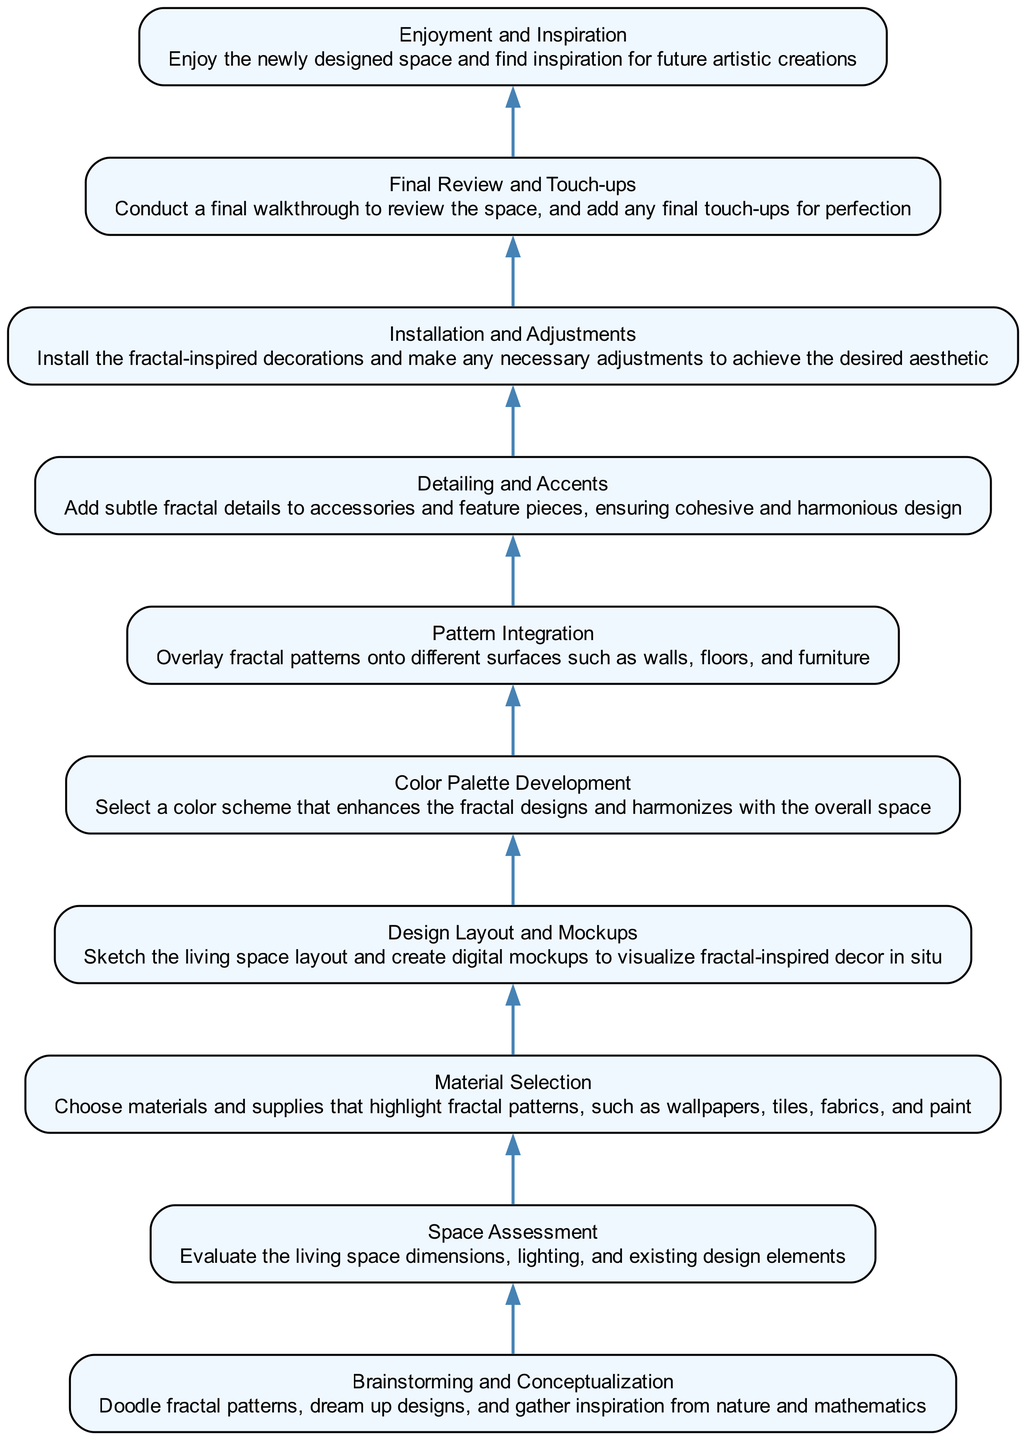What is the first step in the design process? The first step listed in the diagram is "Brainstorming and Conceptualization," which entails doodling fractal patterns and gathering inspiration.
Answer: Brainstorming and Conceptualization How many nodes are present in the diagram? The diagram contains ten nodes, each representing a specific step in the design process for creating fractal-inspired decorations.
Answer: Ten What is the final step in the process? The last step indicated in the diagram is "Enjoyment and Inspiration," where one enjoys the newly designed space and finds inspiration for future creations.
Answer: Enjoyment and Inspiration Which step comes directly after "Material Selection"? The step that follows "Material Selection" is "Design Layout and Mockups," which involves sketching the layout and creating digital mockups.
Answer: Design Layout and Mockups What does "Detailing and Accents" involve? "Detailing and Accents" refers to adding subtle fractal details to accessories and feature pieces to maintain a cohesive design.
Answer: Subtle fractal details How many steps involve integrating patterns into surfaces? There are two steps that involve integrating patterns into surfaces: "Pattern Integration," which overlays fractal patterns onto various surfaces, and "Detailing and Accents," where details are added to accessories and decor pieces.
Answer: Two What step evaluates the living space dimensions? The step that focuses on evaluating living space dimensions is titled "Space Assessment," where factors like lighting and existing elements are considered.
Answer: Space Assessment What color scheme is developed after "Design Layout and Mockups"? Following "Design Layout and Mockups," the diagram indicates that a "Color Palette Development" step occurs, where a color scheme to enhance the fractal designs is selected.
Answer: Color Palette Development Which step requires installation? The step that involves installation is "Installation and Adjustments," where decorations are installed, and adjustments are made to achieve the desired look.
Answer: Installation and Adjustments 